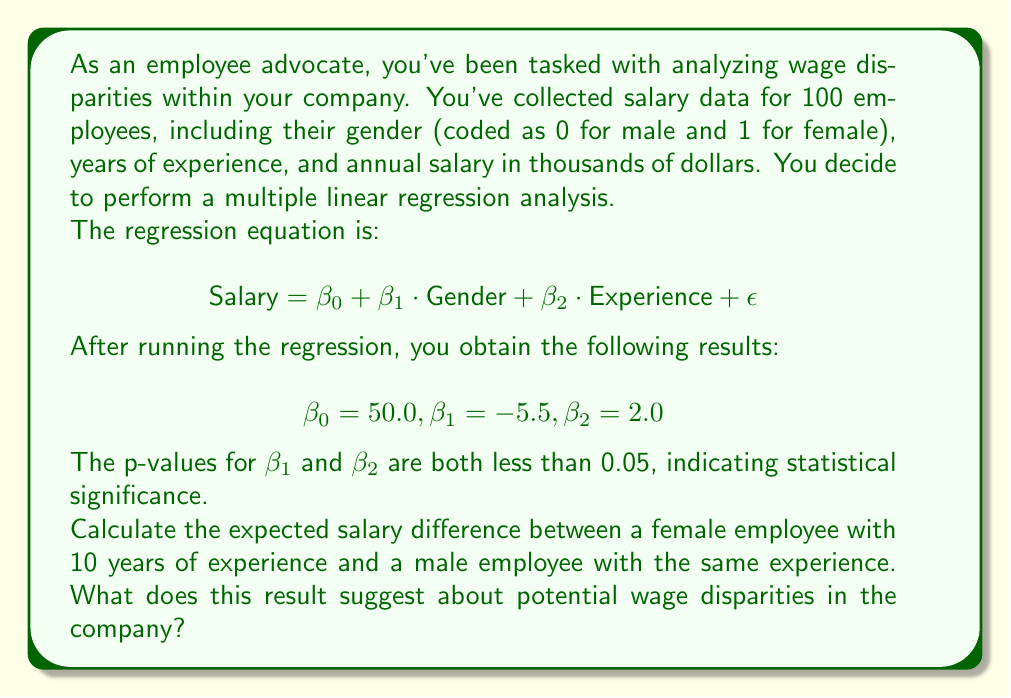Show me your answer to this math problem. To solve this problem, we need to use the multiple linear regression equation and the given coefficients. Let's break it down step-by-step:

1. The regression equation is:
   $$ \text{Salary} = \beta_0 + \beta_1 \cdot \text{Gender} + \beta_2 \cdot \text{Experience} + \epsilon $$

2. We're given the following coefficients:
   $$ \beta_0 = 50.0, \beta_1 = -5.5, \beta_2 = 2.0 $$

3. To find the expected salary difference, we need to calculate the salary for both a female and a male employee with 10 years of experience:

   For a female employee (Gender = 1):
   $$ \text{Salary}_{\text{female}} = 50.0 + (-5.5 \cdot 1) + (2.0 \cdot 10) $$
   $$ \text{Salary}_{\text{female}} = 50.0 - 5.5 + 20.0 = 64.5 $$

   For a male employee (Gender = 0):
   $$ \text{Salary}_{\text{male}} = 50.0 + (-5.5 \cdot 0) + (2.0 \cdot 10) $$
   $$ \text{Salary}_{\text{male}} = 50.0 + 0 + 20.0 = 70.0 $$

4. The expected salary difference is:
   $$ \text{Difference} = \text{Salary}_{\text{male}} - \text{Salary}_{\text{female}} $$
   $$ \text{Difference} = 70.0 - 64.5 = 5.5 $$

This result suggests that, on average, a male employee is expected to earn $5,500 more per year than a female employee with the same years of experience. The negative coefficient for Gender ($\beta_1 = -5.5$) indicates that being female (Gender = 1) is associated with a lower salary, all else being equal.

The statistical significance of the Gender coefficient (p-value < 0.05) suggests that this difference is unlikely to be due to chance. This analysis provides evidence of a potential gender-based wage disparity within the company, which warrants further investigation and possibly corrective action to ensure fair compensation practices.
Answer: The expected salary difference is $5,500 per year, with male employees earning more on average. This suggests a significant gender-based wage disparity within the company. 